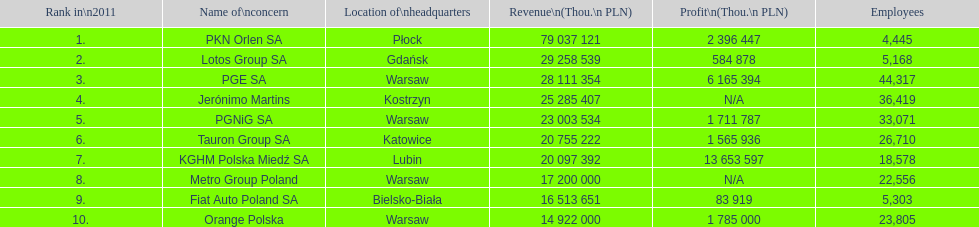Which organization has the unique distinction of having a revenue exceeding 75,000,000 thousand pln? PKN Orlen SA. 